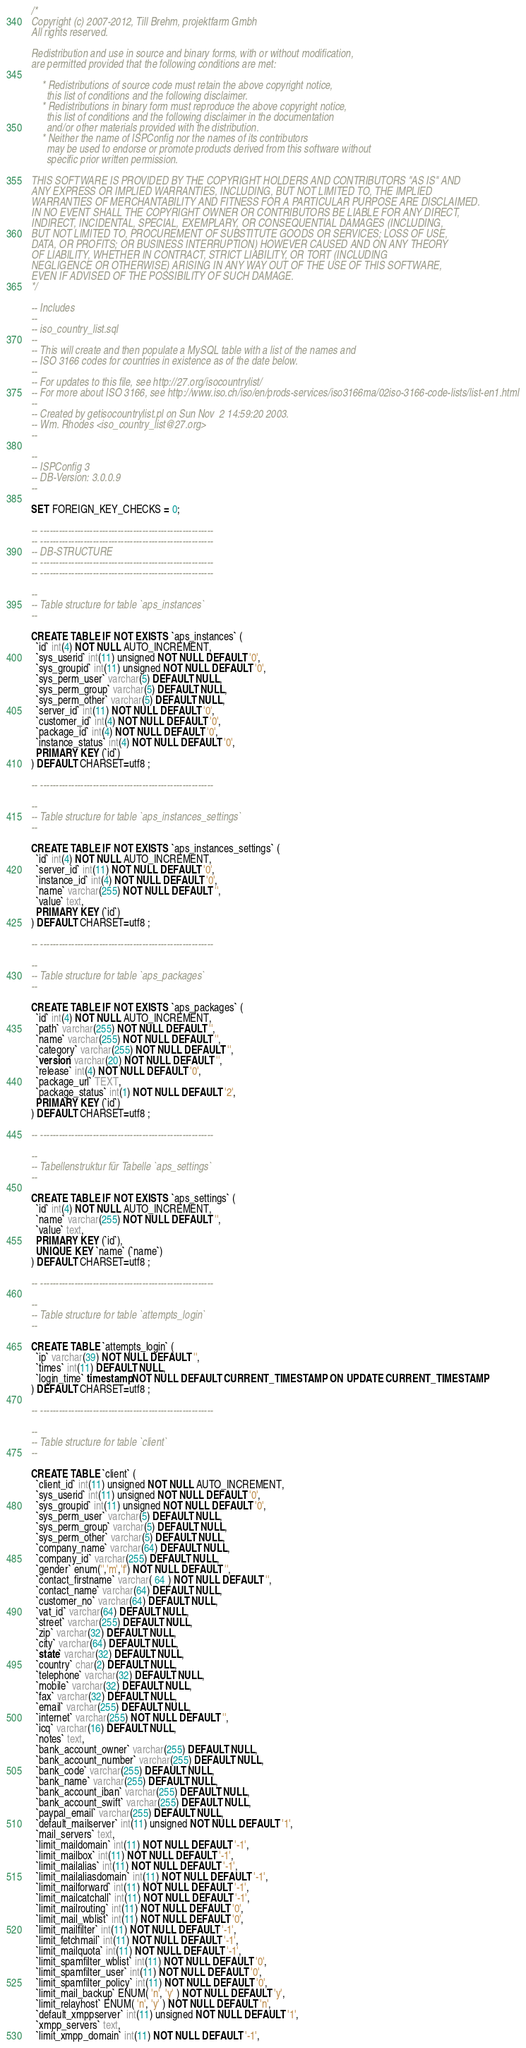<code> <loc_0><loc_0><loc_500><loc_500><_SQL_>/*
Copyright (c) 2007-2012, Till Brehm, projektfarm Gmbh
All rights reserved.

Redistribution and use in source and binary forms, with or without modification,
are permitted provided that the following conditions are met:

    * Redistributions of source code must retain the above copyright notice,
      this list of conditions and the following disclaimer.
    * Redistributions in binary form must reproduce the above copyright notice,
      this list of conditions and the following disclaimer in the documentation
      and/or other materials provided with the distribution.
    * Neither the name of ISPConfig nor the names of its contributors
      may be used to endorse or promote products derived from this software without
      specific prior written permission.

THIS SOFTWARE IS PROVIDED BY THE COPYRIGHT HOLDERS AND CONTRIBUTORS "AS IS" AND
ANY EXPRESS OR IMPLIED WARRANTIES, INCLUDING, BUT NOT LIMITED TO, THE IMPLIED
WARRANTIES OF MERCHANTABILITY AND FITNESS FOR A PARTICULAR PURPOSE ARE DISCLAIMED.
IN NO EVENT SHALL THE COPYRIGHT OWNER OR CONTRIBUTORS BE LIABLE FOR ANY DIRECT,
INDIRECT, INCIDENTAL, SPECIAL, EXEMPLARY, OR CONSEQUENTIAL DAMAGES (INCLUDING,
BUT NOT LIMITED TO, PROCUREMENT OF SUBSTITUTE GOODS OR SERVICES; LOSS OF USE,
DATA, OR PROFITS; OR BUSINESS INTERRUPTION) HOWEVER CAUSED AND ON ANY THEORY
OF LIABILITY, WHETHER IN CONTRACT, STRICT LIABILITY, OR TORT (INCLUDING
NEGLIGENCE OR OTHERWISE) ARISING IN ANY WAY OUT OF THE USE OF THIS SOFTWARE,
EVEN IF ADVISED OF THE POSSIBILITY OF SUCH DAMAGE.
*/

-- Includes
--
-- iso_country_list.sql
--
-- This will create and then populate a MySQL table with a list of the names and
-- ISO 3166 codes for countries in existence as of the date below.
--
-- For updates to this file, see http://27.org/isocountrylist/
-- For more about ISO 3166, see http://www.iso.ch/iso/en/prods-services/iso3166ma/02iso-3166-code-lists/list-en1.html
--
-- Created by getisocountrylist.pl on Sun Nov  2 14:59:20 2003.
-- Wm. Rhodes <iso_country_list@27.org>
--

--
-- ISPConfig 3
-- DB-Version: 3.0.0.9
--

SET FOREIGN_KEY_CHECKS = 0;

-- --------------------------------------------------------
-- --------------------------------------------------------
-- DB-STRUCTURE
-- --------------------------------------------------------
-- --------------------------------------------------------

--
-- Table structure for table `aps_instances`
--

CREATE TABLE IF NOT EXISTS `aps_instances` (
  `id` int(4) NOT NULL AUTO_INCREMENT,
  `sys_userid` int(11) unsigned NOT NULL DEFAULT '0',
  `sys_groupid` int(11) unsigned NOT NULL DEFAULT '0',
  `sys_perm_user` varchar(5) DEFAULT NULL,
  `sys_perm_group` varchar(5) DEFAULT NULL,
  `sys_perm_other` varchar(5) DEFAULT NULL,
  `server_id` int(11) NOT NULL DEFAULT '0',
  `customer_id` int(4) NOT NULL DEFAULT '0',
  `package_id` int(4) NOT NULL DEFAULT '0',
  `instance_status` int(4) NOT NULL DEFAULT '0',
  PRIMARY KEY (`id`)
) DEFAULT CHARSET=utf8 ;

-- --------------------------------------------------------

--
-- Table structure for table `aps_instances_settings`
--

CREATE TABLE IF NOT EXISTS `aps_instances_settings` (
  `id` int(4) NOT NULL AUTO_INCREMENT,
  `server_id` int(11) NOT NULL DEFAULT '0',
  `instance_id` int(4) NOT NULL DEFAULT '0',
  `name` varchar(255) NOT NULL DEFAULT '',
  `value` text,
  PRIMARY KEY (`id`)
) DEFAULT CHARSET=utf8 ;

-- --------------------------------------------------------

--
-- Table structure for table `aps_packages`
--

CREATE TABLE IF NOT EXISTS `aps_packages` (
  `id` int(4) NOT NULL AUTO_INCREMENT,
  `path` varchar(255) NOT NULL DEFAULT '',
  `name` varchar(255) NOT NULL DEFAULT '',
  `category` varchar(255) NOT NULL DEFAULT '',
  `version` varchar(20) NOT NULL DEFAULT '',
  `release` int(4) NOT NULL DEFAULT '0',
  `package_url` TEXT,
  `package_status` int(1) NOT NULL DEFAULT '2',
  PRIMARY KEY (`id`)
) DEFAULT CHARSET=utf8 ;

-- --------------------------------------------------------

--
-- Tabellenstruktur für Tabelle `aps_settings`
--

CREATE TABLE IF NOT EXISTS `aps_settings` (
  `id` int(4) NOT NULL AUTO_INCREMENT,
  `name` varchar(255) NOT NULL DEFAULT '',
  `value` text,
  PRIMARY KEY (`id`),
  UNIQUE KEY `name` (`name`)
) DEFAULT CHARSET=utf8 ;

-- --------------------------------------------------------

--
-- Table structure for table `attempts_login`
--

CREATE TABLE `attempts_login` (
  `ip` varchar(39) NOT NULL DEFAULT '',
  `times` int(11) DEFAULT NULL,
  `login_time` timestamp NOT NULL DEFAULT CURRENT_TIMESTAMP ON UPDATE CURRENT_TIMESTAMP
) DEFAULT CHARSET=utf8 ;

-- --------------------------------------------------------

--
-- Table structure for table `client`
--

CREATE TABLE `client` (
  `client_id` int(11) unsigned NOT NULL AUTO_INCREMENT,
  `sys_userid` int(11) unsigned NOT NULL DEFAULT '0',
  `sys_groupid` int(11) unsigned NOT NULL DEFAULT '0',
  `sys_perm_user` varchar(5) DEFAULT NULL,
  `sys_perm_group` varchar(5) DEFAULT NULL,
  `sys_perm_other` varchar(5) DEFAULT NULL,
  `company_name` varchar(64) DEFAULT NULL,
  `company_id` varchar(255) DEFAULT NULL,
  `gender` enum('','m','f') NOT NULL DEFAULT '',
  `contact_firstname` varchar( 64 ) NOT NULL DEFAULT '',
  `contact_name` varchar(64) DEFAULT NULL,
  `customer_no` varchar(64) DEFAULT NULL,
  `vat_id` varchar(64) DEFAULT NULL,
  `street` varchar(255) DEFAULT NULL,
  `zip` varchar(32) DEFAULT NULL,
  `city` varchar(64) DEFAULT NULL,
  `state` varchar(32) DEFAULT NULL,
  `country` char(2) DEFAULT NULL,
  `telephone` varchar(32) DEFAULT NULL,
  `mobile` varchar(32) DEFAULT NULL,
  `fax` varchar(32) DEFAULT NULL,
  `email` varchar(255) DEFAULT NULL,
  `internet` varchar(255) NOT NULL DEFAULT '',
  `icq` varchar(16) DEFAULT NULL,
  `notes` text,
  `bank_account_owner` varchar(255) DEFAULT NULL,
  `bank_account_number` varchar(255) DEFAULT NULL,
  `bank_code` varchar(255) DEFAULT NULL,
  `bank_name` varchar(255) DEFAULT NULL,
  `bank_account_iban` varchar(255) DEFAULT NULL,
  `bank_account_swift` varchar(255) DEFAULT NULL,
  `paypal_email` varchar(255) DEFAULT NULL,
  `default_mailserver` int(11) unsigned NOT NULL DEFAULT '1',
  `mail_servers` text,
  `limit_maildomain` int(11) NOT NULL DEFAULT '-1',
  `limit_mailbox` int(11) NOT NULL DEFAULT '-1',
  `limit_mailalias` int(11) NOT NULL DEFAULT '-1',
  `limit_mailaliasdomain` int(11) NOT NULL DEFAULT '-1',
  `limit_mailforward` int(11) NOT NULL DEFAULT '-1',
  `limit_mailcatchall` int(11) NOT NULL DEFAULT '-1',
  `limit_mailrouting` int(11) NOT NULL DEFAULT '0',
  `limit_mail_wblist` int(11) NOT NULL DEFAULT '0',
  `limit_mailfilter` int(11) NOT NULL DEFAULT '-1',
  `limit_fetchmail` int(11) NOT NULL DEFAULT '-1',
  `limit_mailquota` int(11) NOT NULL DEFAULT '-1',
  `limit_spamfilter_wblist` int(11) NOT NULL DEFAULT '0',
  `limit_spamfilter_user` int(11) NOT NULL DEFAULT '0',
  `limit_spamfilter_policy` int(11) NOT NULL DEFAULT '0',
  `limit_mail_backup` ENUM( 'n', 'y' ) NOT NULL DEFAULT 'y',
  `limit_relayhost` ENUM( 'n', 'y' ) NOT NULL DEFAULT 'n',
  `default_xmppserver` int(11) unsigned NOT NULL DEFAULT '1',
  `xmpp_servers` text,
  `limit_xmpp_domain` int(11) NOT NULL DEFAULT '-1',</code> 